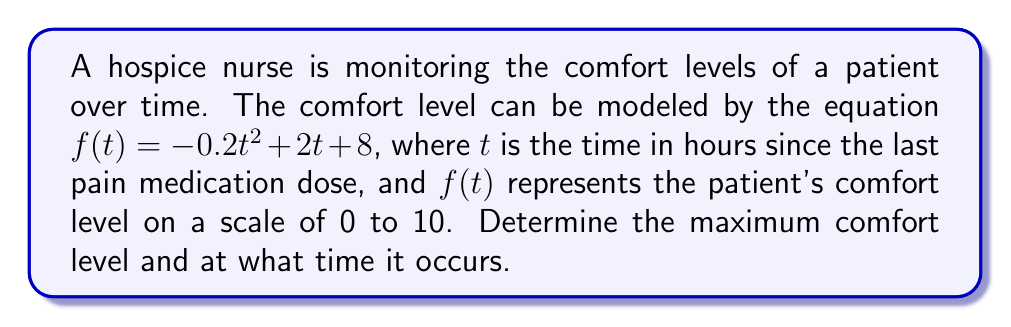Give your solution to this math problem. To find the maximum comfort level and the time it occurs, we need to follow these steps:

1) The function $f(t) = -0.2t^2 + 2t + 8$ is a quadratic function, which forms a parabola. The maximum point of a parabola occurs at its vertex.

2) For a quadratic function in the form $f(t) = at^2 + bt + c$, the t-coordinate of the vertex is given by $t = -\frac{b}{2a}$.

3) In our case, $a = -0.2$ and $b = 2$. Let's substitute these values:

   $t = -\frac{2}{2(-0.2)} = -\frac{2}{-0.4} = 5$

4) To find the maximum comfort level, we need to calculate $f(5)$:

   $f(5) = -0.2(5)^2 + 2(5) + 8$
   $= -0.2(25) + 10 + 8$
   $= -5 + 10 + 8$
   $= 13$

5) However, since our scale is from 0 to 10, the maximum comfort level is capped at 10.

Therefore, the maximum comfort level is 10, occurring 5 hours after the last pain medication dose.
Answer: Maximum comfort level: 10; Time: 5 hours after dose 